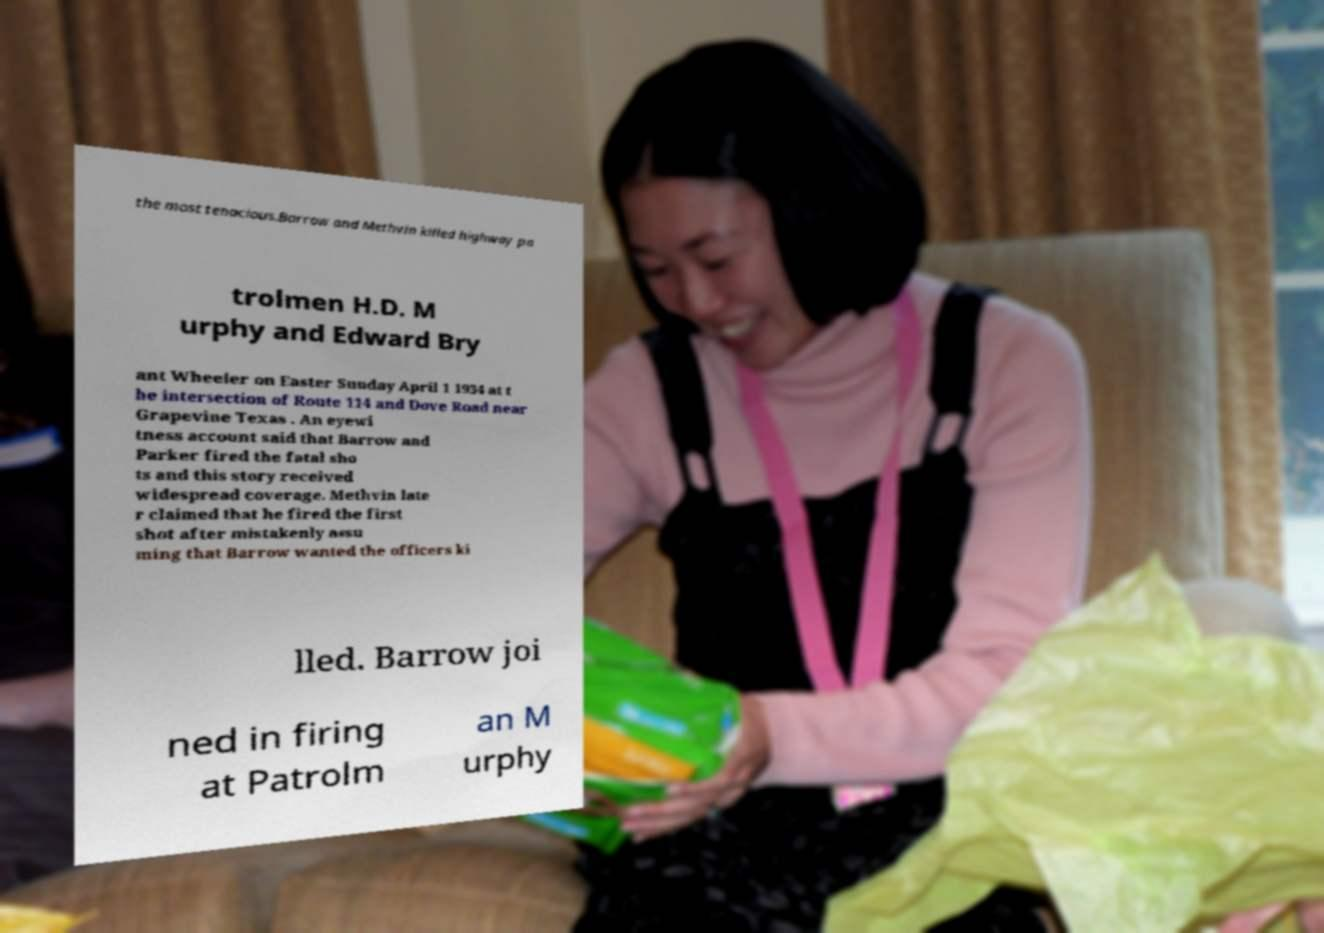Please identify and transcribe the text found in this image. the most tenacious.Barrow and Methvin killed highway pa trolmen H.D. M urphy and Edward Bry ant Wheeler on Easter Sunday April 1 1934 at t he intersection of Route 114 and Dove Road near Grapevine Texas . An eyewi tness account said that Barrow and Parker fired the fatal sho ts and this story received widespread coverage. Methvin late r claimed that he fired the first shot after mistakenly assu ming that Barrow wanted the officers ki lled. Barrow joi ned in firing at Patrolm an M urphy 